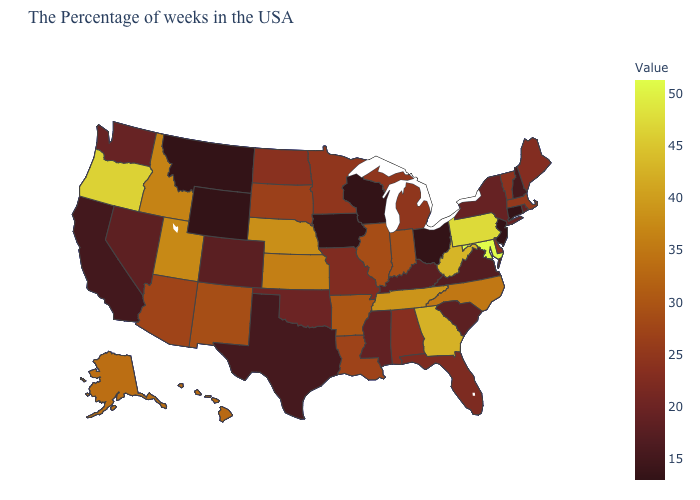Among the states that border Arkansas , does Texas have the lowest value?
Write a very short answer. Yes. Among the states that border Wyoming , which have the lowest value?
Write a very short answer. Montana. Among the states that border South Dakota , does North Dakota have the lowest value?
Short answer required. No. Which states hav the highest value in the MidWest?
Concise answer only. Nebraska. Which states have the lowest value in the USA?
Write a very short answer. Connecticut, New Jersey, Ohio, Wisconsin, Iowa, Wyoming, Montana. 